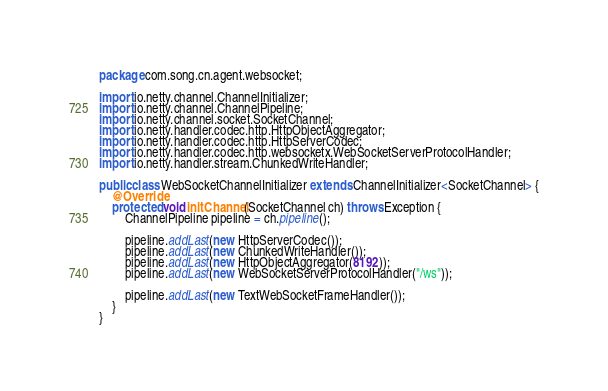Convert code to text. <code><loc_0><loc_0><loc_500><loc_500><_Java_>package com.song.cn.agent.websocket;

import io.netty.channel.ChannelInitializer;
import io.netty.channel.ChannelPipeline;
import io.netty.channel.socket.SocketChannel;
import io.netty.handler.codec.http.HttpObjectAggregator;
import io.netty.handler.codec.http.HttpServerCodec;
import io.netty.handler.codec.http.websocketx.WebSocketServerProtocolHandler;
import io.netty.handler.stream.ChunkedWriteHandler;

public class WebSocketChannelInitializer extends ChannelInitializer<SocketChannel> {
    @Override
    protected void initChannel(SocketChannel ch) throws Exception {
        ChannelPipeline pipeline = ch.pipeline();

        pipeline.addLast(new HttpServerCodec());
        pipeline.addLast(new ChunkedWriteHandler());
        pipeline.addLast(new HttpObjectAggregator(8192));
        pipeline.addLast(new WebSocketServerProtocolHandler("/ws"));

        pipeline.addLast(new TextWebSocketFrameHandler());
    }
}
</code> 